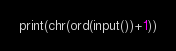<code> <loc_0><loc_0><loc_500><loc_500><_Python_>print(chr(ord(input())+1))</code> 